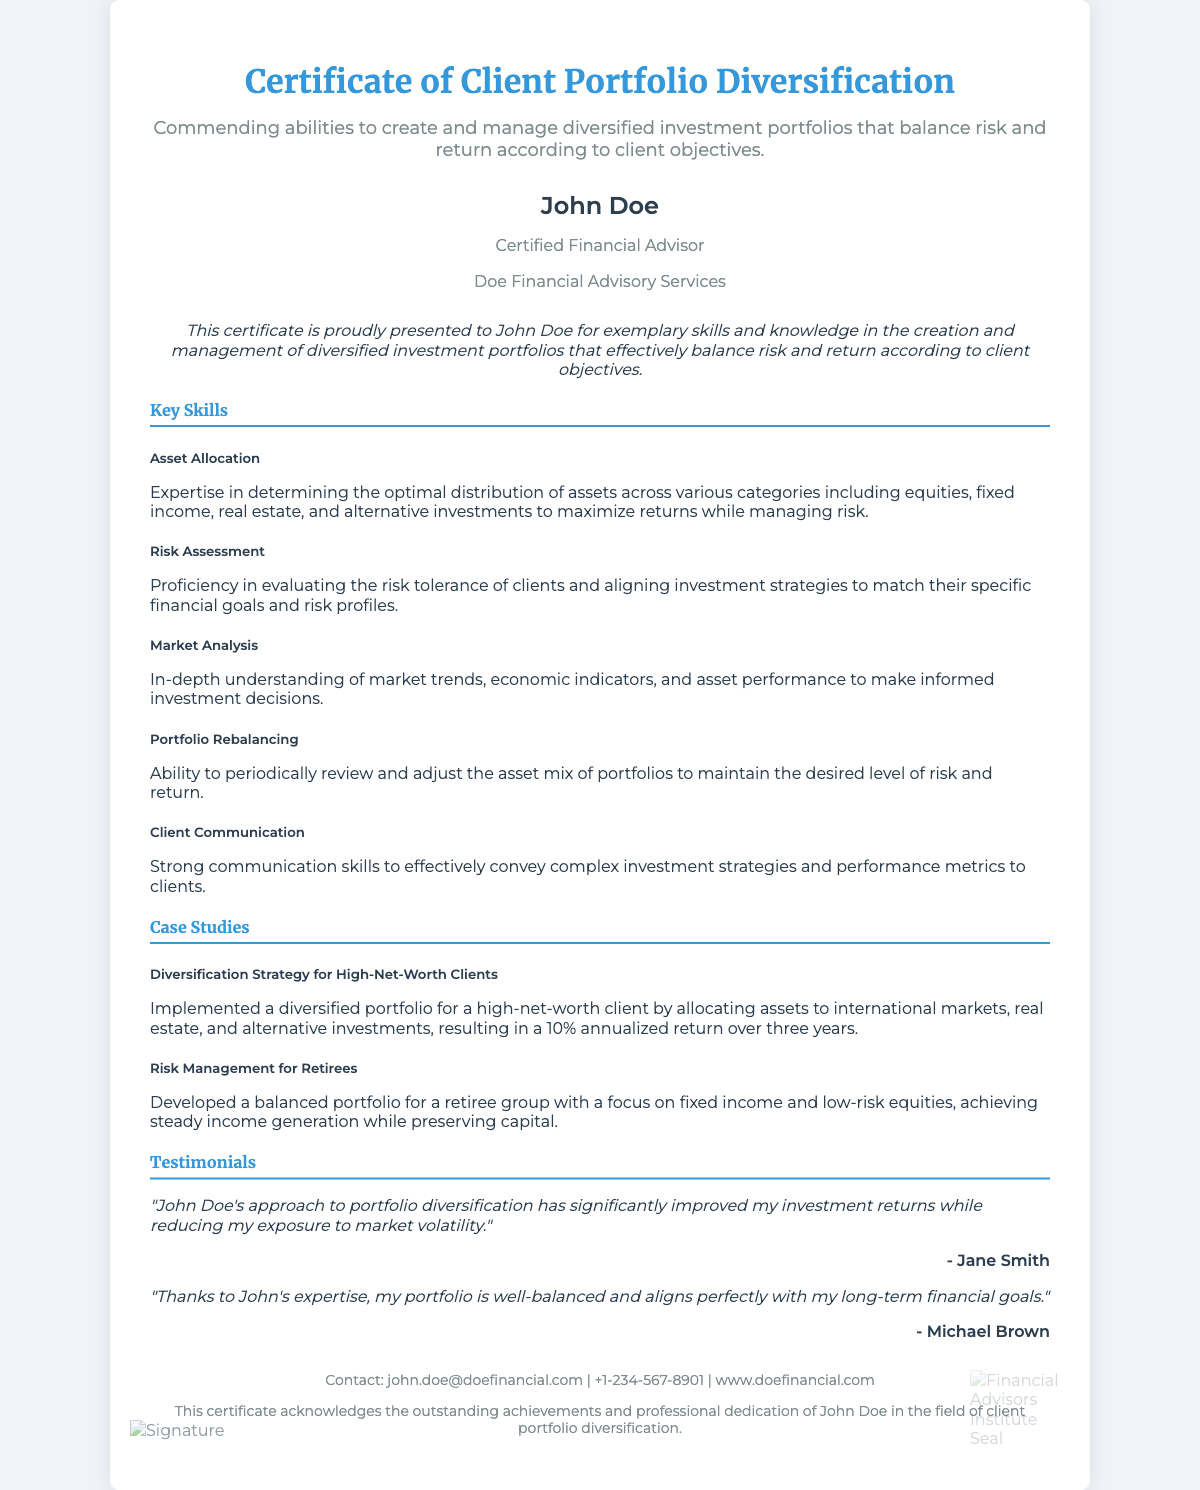What is the title of the certificate? The title of the certificate is prominently displayed at the top and is "Certificate of Client Portfolio Diversification."
Answer: Certificate of Client Portfolio Diversification Who is the recipient of the certificate? The certificate states the recipient's name in the designated section, which is "John Doe."
Answer: John Doe What is the primary skill commended in this certificate? The certificate highlights the ability to create and manage diversified investment portfolios as the primary skill.
Answer: Create and manage diversified investment portfolios What is the annualized return achieved for high-net-worth clients? The case study mentions the achievement for high-net-worth clients, which is a "10% annualized return over three years."
Answer: 10% What type of clients is the risk management strategy developed for? The document specifies that the risk management strategy was developed for a "retiree group."
Answer: Retiree group What is a key skill related to evaluating client risk? One of the key skills listed involves evaluating the risk tolerance of clients.
Answer: Risk Assessment What does the certificate indicate about John Doe's professional dedication? The certificate acknowledges John Doe’s dedication in the field of client portfolio diversification.
Answer: Outstanding achievements and professional dedication What is the contact email provided in the footer? The footer of the certificate lists the contact email, which is "john.doe@doefinancial.com."
Answer: john.doe@doefinancial.com What type of investments are mentioned in the diversification strategy case study? The case study mentions allocations to "international markets, real estate, and alternative investments."
Answer: International markets, real estate, and alternative investments 